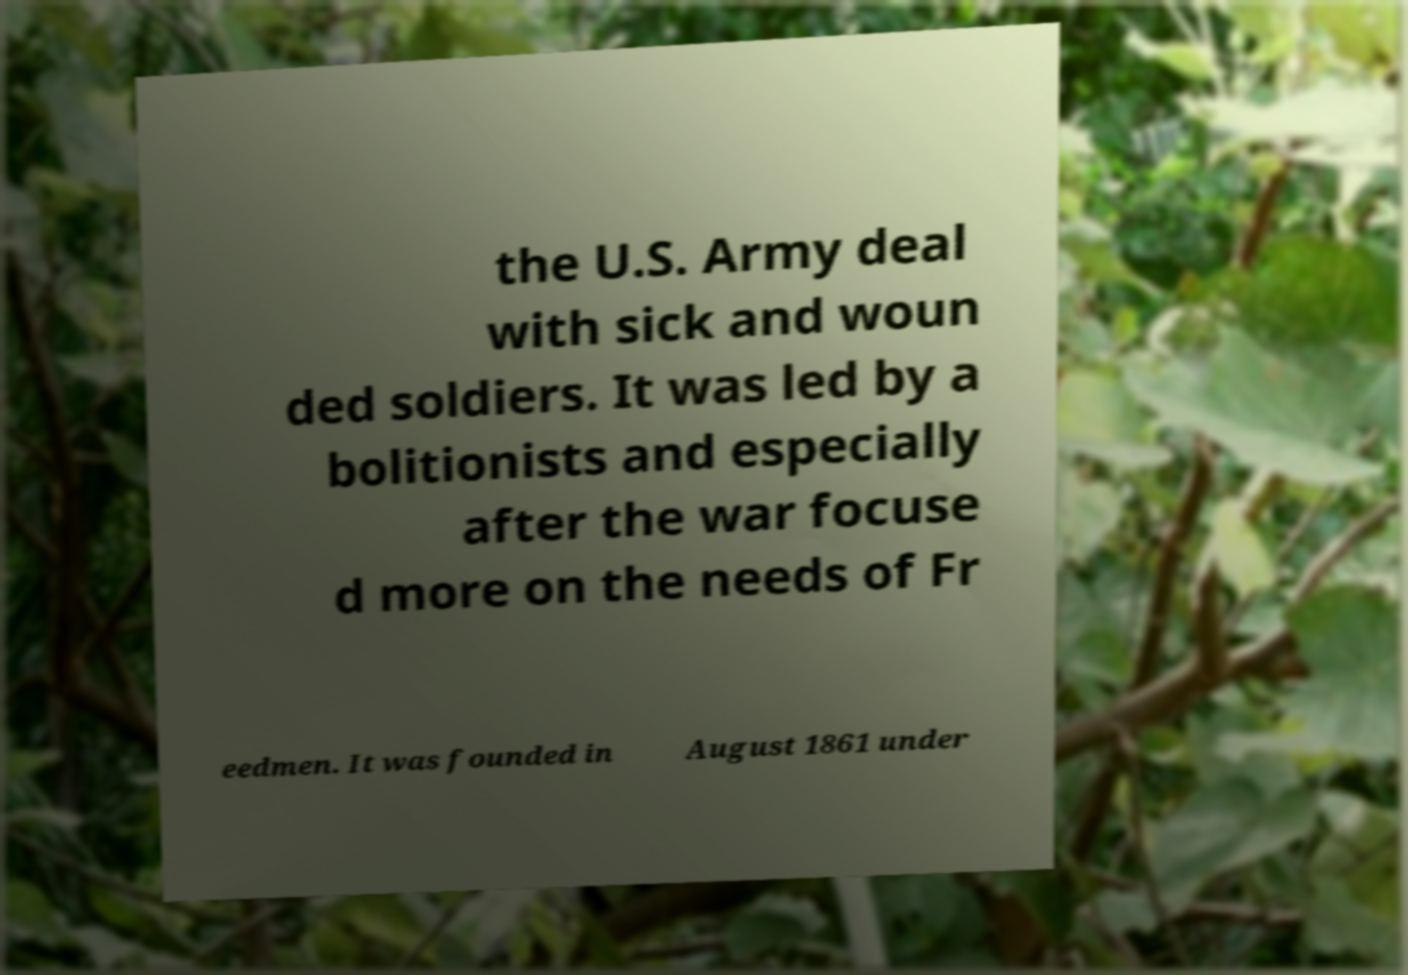Please identify and transcribe the text found in this image. the U.S. Army deal with sick and woun ded soldiers. It was led by a bolitionists and especially after the war focuse d more on the needs of Fr eedmen. It was founded in August 1861 under 